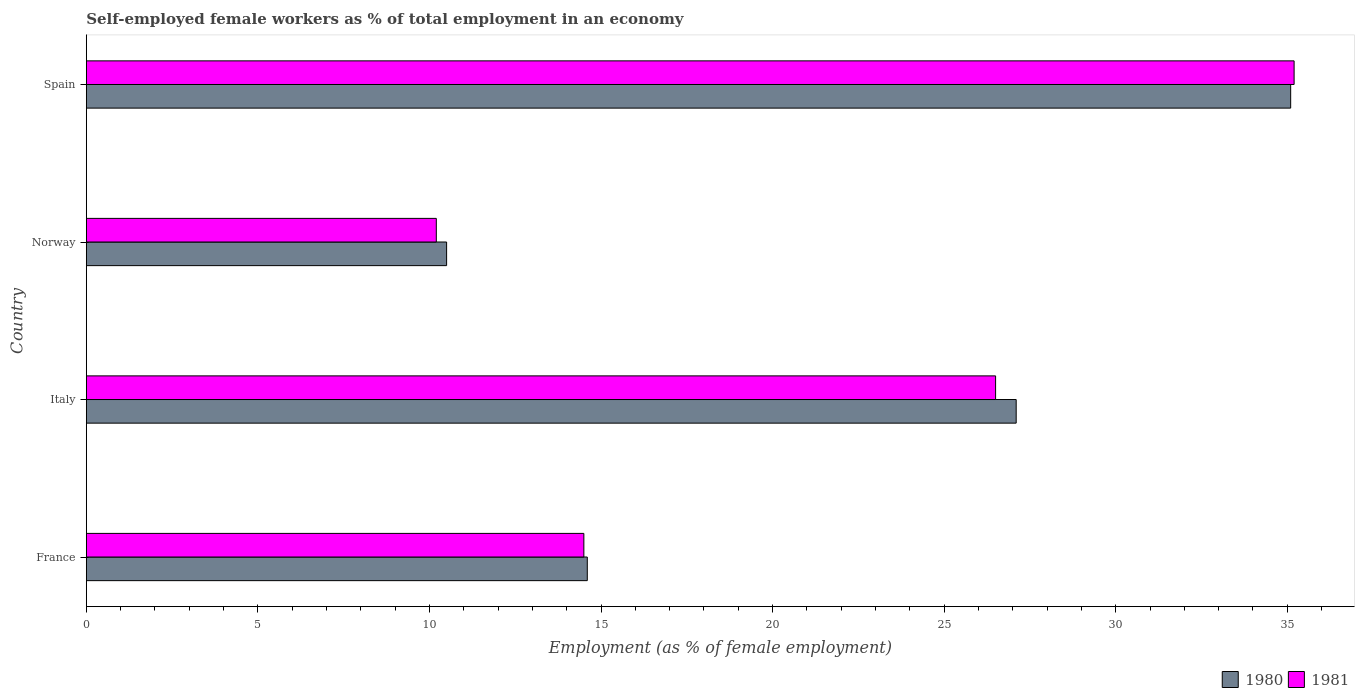How many different coloured bars are there?
Make the answer very short. 2. How many groups of bars are there?
Your answer should be very brief. 4. How many bars are there on the 2nd tick from the top?
Your response must be concise. 2. How many bars are there on the 1st tick from the bottom?
Give a very brief answer. 2. What is the label of the 4th group of bars from the top?
Offer a very short reply. France. What is the percentage of self-employed female workers in 1980 in France?
Your response must be concise. 14.6. Across all countries, what is the maximum percentage of self-employed female workers in 1981?
Your answer should be very brief. 35.2. Across all countries, what is the minimum percentage of self-employed female workers in 1981?
Ensure brevity in your answer.  10.2. What is the total percentage of self-employed female workers in 1981 in the graph?
Give a very brief answer. 86.4. What is the difference between the percentage of self-employed female workers in 1981 in France and that in Norway?
Ensure brevity in your answer.  4.3. What is the difference between the percentage of self-employed female workers in 1980 in Spain and the percentage of self-employed female workers in 1981 in Norway?
Keep it short and to the point. 24.9. What is the average percentage of self-employed female workers in 1980 per country?
Give a very brief answer. 21.82. What is the difference between the percentage of self-employed female workers in 1980 and percentage of self-employed female workers in 1981 in Spain?
Offer a terse response. -0.1. In how many countries, is the percentage of self-employed female workers in 1981 greater than 5 %?
Give a very brief answer. 4. What is the ratio of the percentage of self-employed female workers in 1980 in Norway to that in Spain?
Provide a short and direct response. 0.3. Is the percentage of self-employed female workers in 1980 in Norway less than that in Spain?
Provide a succinct answer. Yes. Is the difference between the percentage of self-employed female workers in 1980 in France and Spain greater than the difference between the percentage of self-employed female workers in 1981 in France and Spain?
Your answer should be very brief. Yes. What is the difference between the highest and the second highest percentage of self-employed female workers in 1980?
Keep it short and to the point. 8. What is the difference between the highest and the lowest percentage of self-employed female workers in 1981?
Offer a terse response. 25. In how many countries, is the percentage of self-employed female workers in 1980 greater than the average percentage of self-employed female workers in 1980 taken over all countries?
Offer a very short reply. 2. Is the sum of the percentage of self-employed female workers in 1981 in France and Italy greater than the maximum percentage of self-employed female workers in 1980 across all countries?
Your answer should be very brief. Yes. Are all the bars in the graph horizontal?
Offer a very short reply. Yes. What is the difference between two consecutive major ticks on the X-axis?
Ensure brevity in your answer.  5. Are the values on the major ticks of X-axis written in scientific E-notation?
Ensure brevity in your answer.  No. Does the graph contain any zero values?
Offer a very short reply. No. Where does the legend appear in the graph?
Provide a short and direct response. Bottom right. How many legend labels are there?
Your answer should be compact. 2. How are the legend labels stacked?
Ensure brevity in your answer.  Horizontal. What is the title of the graph?
Offer a terse response. Self-employed female workers as % of total employment in an economy. What is the label or title of the X-axis?
Your answer should be compact. Employment (as % of female employment). What is the label or title of the Y-axis?
Make the answer very short. Country. What is the Employment (as % of female employment) of 1980 in France?
Offer a very short reply. 14.6. What is the Employment (as % of female employment) of 1981 in France?
Offer a very short reply. 14.5. What is the Employment (as % of female employment) in 1980 in Italy?
Make the answer very short. 27.1. What is the Employment (as % of female employment) in 1981 in Italy?
Provide a succinct answer. 26.5. What is the Employment (as % of female employment) of 1981 in Norway?
Give a very brief answer. 10.2. What is the Employment (as % of female employment) in 1980 in Spain?
Keep it short and to the point. 35.1. What is the Employment (as % of female employment) of 1981 in Spain?
Ensure brevity in your answer.  35.2. Across all countries, what is the maximum Employment (as % of female employment) of 1980?
Your answer should be very brief. 35.1. Across all countries, what is the maximum Employment (as % of female employment) of 1981?
Provide a succinct answer. 35.2. Across all countries, what is the minimum Employment (as % of female employment) of 1981?
Your answer should be compact. 10.2. What is the total Employment (as % of female employment) of 1980 in the graph?
Provide a succinct answer. 87.3. What is the total Employment (as % of female employment) of 1981 in the graph?
Offer a terse response. 86.4. What is the difference between the Employment (as % of female employment) in 1980 in France and that in Italy?
Your answer should be very brief. -12.5. What is the difference between the Employment (as % of female employment) in 1981 in France and that in Italy?
Offer a very short reply. -12. What is the difference between the Employment (as % of female employment) of 1981 in France and that in Norway?
Your response must be concise. 4.3. What is the difference between the Employment (as % of female employment) of 1980 in France and that in Spain?
Offer a very short reply. -20.5. What is the difference between the Employment (as % of female employment) of 1981 in France and that in Spain?
Provide a short and direct response. -20.7. What is the difference between the Employment (as % of female employment) in 1980 in Italy and that in Norway?
Make the answer very short. 16.6. What is the difference between the Employment (as % of female employment) of 1981 in Italy and that in Norway?
Ensure brevity in your answer.  16.3. What is the difference between the Employment (as % of female employment) of 1981 in Italy and that in Spain?
Your response must be concise. -8.7. What is the difference between the Employment (as % of female employment) of 1980 in Norway and that in Spain?
Keep it short and to the point. -24.6. What is the difference between the Employment (as % of female employment) in 1980 in France and the Employment (as % of female employment) in 1981 in Norway?
Give a very brief answer. 4.4. What is the difference between the Employment (as % of female employment) of 1980 in France and the Employment (as % of female employment) of 1981 in Spain?
Offer a very short reply. -20.6. What is the difference between the Employment (as % of female employment) in 1980 in Italy and the Employment (as % of female employment) in 1981 in Norway?
Ensure brevity in your answer.  16.9. What is the difference between the Employment (as % of female employment) in 1980 in Italy and the Employment (as % of female employment) in 1981 in Spain?
Keep it short and to the point. -8.1. What is the difference between the Employment (as % of female employment) in 1980 in Norway and the Employment (as % of female employment) in 1981 in Spain?
Offer a very short reply. -24.7. What is the average Employment (as % of female employment) of 1980 per country?
Ensure brevity in your answer.  21.82. What is the average Employment (as % of female employment) of 1981 per country?
Make the answer very short. 21.6. What is the difference between the Employment (as % of female employment) of 1980 and Employment (as % of female employment) of 1981 in France?
Make the answer very short. 0.1. What is the difference between the Employment (as % of female employment) of 1980 and Employment (as % of female employment) of 1981 in Italy?
Offer a terse response. 0.6. What is the difference between the Employment (as % of female employment) of 1980 and Employment (as % of female employment) of 1981 in Norway?
Make the answer very short. 0.3. What is the difference between the Employment (as % of female employment) in 1980 and Employment (as % of female employment) in 1981 in Spain?
Ensure brevity in your answer.  -0.1. What is the ratio of the Employment (as % of female employment) of 1980 in France to that in Italy?
Make the answer very short. 0.54. What is the ratio of the Employment (as % of female employment) in 1981 in France to that in Italy?
Ensure brevity in your answer.  0.55. What is the ratio of the Employment (as % of female employment) of 1980 in France to that in Norway?
Your response must be concise. 1.39. What is the ratio of the Employment (as % of female employment) of 1981 in France to that in Norway?
Your response must be concise. 1.42. What is the ratio of the Employment (as % of female employment) of 1980 in France to that in Spain?
Provide a short and direct response. 0.42. What is the ratio of the Employment (as % of female employment) in 1981 in France to that in Spain?
Offer a terse response. 0.41. What is the ratio of the Employment (as % of female employment) of 1980 in Italy to that in Norway?
Keep it short and to the point. 2.58. What is the ratio of the Employment (as % of female employment) of 1981 in Italy to that in Norway?
Provide a short and direct response. 2.6. What is the ratio of the Employment (as % of female employment) of 1980 in Italy to that in Spain?
Ensure brevity in your answer.  0.77. What is the ratio of the Employment (as % of female employment) in 1981 in Italy to that in Spain?
Your response must be concise. 0.75. What is the ratio of the Employment (as % of female employment) of 1980 in Norway to that in Spain?
Your answer should be very brief. 0.3. What is the ratio of the Employment (as % of female employment) of 1981 in Norway to that in Spain?
Give a very brief answer. 0.29. What is the difference between the highest and the second highest Employment (as % of female employment) of 1980?
Provide a short and direct response. 8. What is the difference between the highest and the second highest Employment (as % of female employment) of 1981?
Provide a succinct answer. 8.7. What is the difference between the highest and the lowest Employment (as % of female employment) of 1980?
Your answer should be very brief. 24.6. 